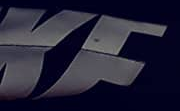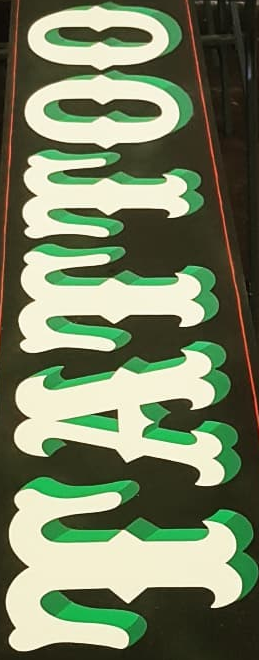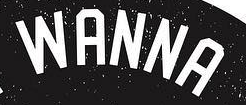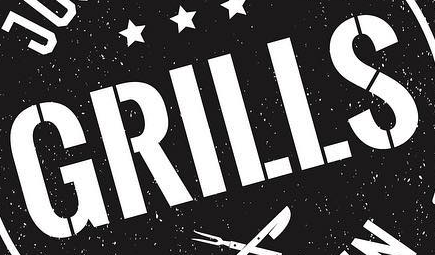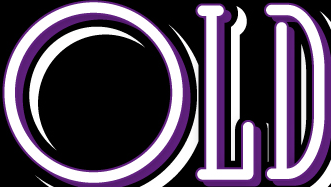Read the text from these images in sequence, separated by a semicolon. KF; TATTOO; WANNA; GRILLS; OLD 